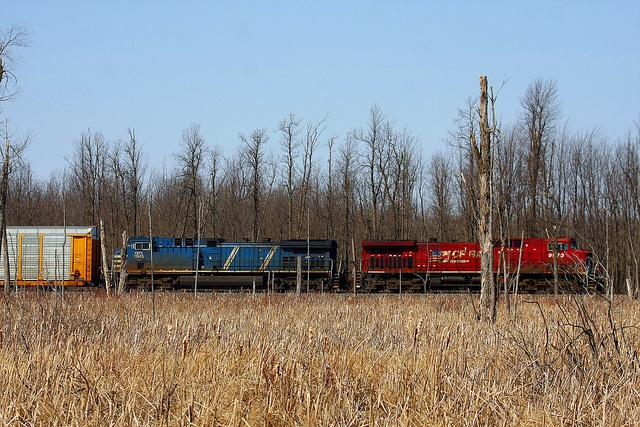Describe the objects in this image and their specific colors. I can see train in lightblue, black, maroon, gray, and darkgray tones and train in lightblue, maroon, black, and gray tones in this image. 